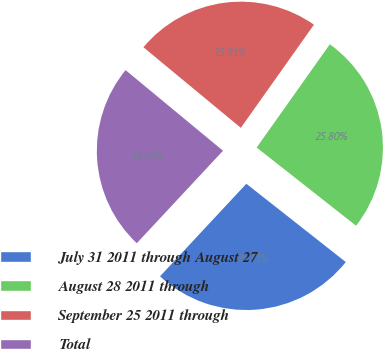Convert chart to OTSL. <chart><loc_0><loc_0><loc_500><loc_500><pie_chart><fcel>July 31 2011 through August 27<fcel>August 28 2011 through<fcel>September 25 2011 through<fcel>Total<nl><fcel>26.33%<fcel>25.8%<fcel>23.81%<fcel>24.06%<nl></chart> 